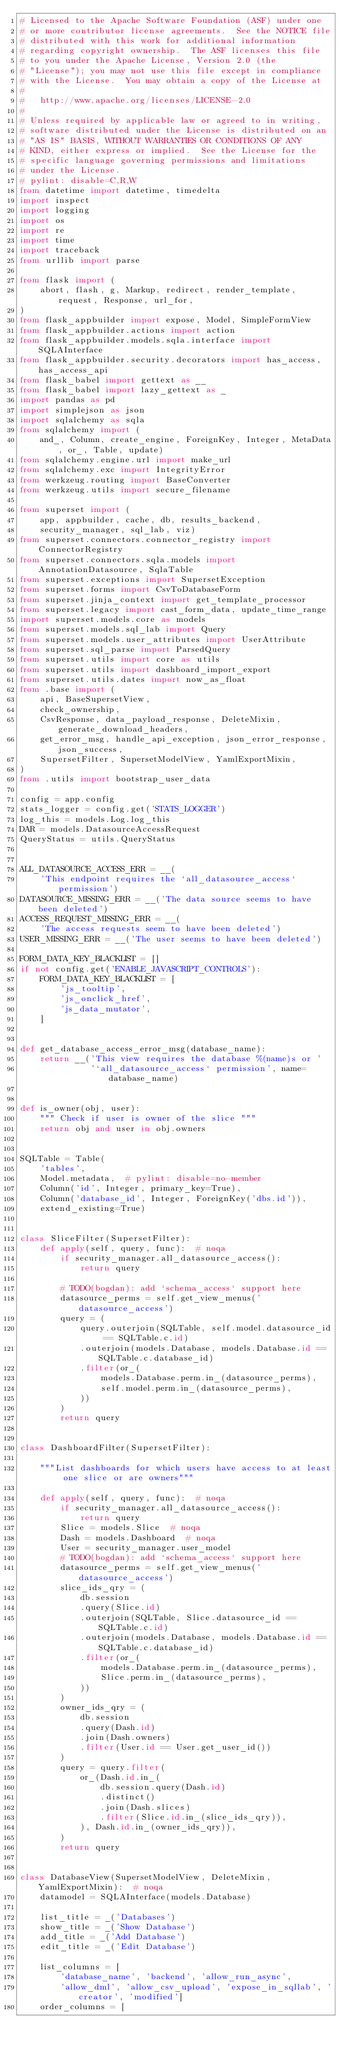Convert code to text. <code><loc_0><loc_0><loc_500><loc_500><_Python_># Licensed to the Apache Software Foundation (ASF) under one
# or more contributor license agreements.  See the NOTICE file
# distributed with this work for additional information
# regarding copyright ownership.  The ASF licenses this file
# to you under the Apache License, Version 2.0 (the
# "License"); you may not use this file except in compliance
# with the License.  You may obtain a copy of the License at
#
#   http://www.apache.org/licenses/LICENSE-2.0
#
# Unless required by applicable law or agreed to in writing,
# software distributed under the License is distributed on an
# "AS IS" BASIS, WITHOUT WARRANTIES OR CONDITIONS OF ANY
# KIND, either express or implied.  See the License for the
# specific language governing permissions and limitations
# under the License.
# pylint: disable=C,R,W
from datetime import datetime, timedelta
import inspect
import logging
import os
import re
import time
import traceback
from urllib import parse

from flask import (
    abort, flash, g, Markup, redirect, render_template, request, Response, url_for,
)
from flask_appbuilder import expose, Model, SimpleFormView
from flask_appbuilder.actions import action
from flask_appbuilder.models.sqla.interface import SQLAInterface
from flask_appbuilder.security.decorators import has_access, has_access_api
from flask_babel import gettext as __
from flask_babel import lazy_gettext as _
import pandas as pd
import simplejson as json
import sqlalchemy as sqla
from sqlalchemy import (
    and_, Column, create_engine, ForeignKey, Integer, MetaData, or_, Table, update)
from sqlalchemy.engine.url import make_url
from sqlalchemy.exc import IntegrityError
from werkzeug.routing import BaseConverter
from werkzeug.utils import secure_filename

from superset import (
    app, appbuilder, cache, db, results_backend,
    security_manager, sql_lab, viz)
from superset.connectors.connector_registry import ConnectorRegistry
from superset.connectors.sqla.models import AnnotationDatasource, SqlaTable
from superset.exceptions import SupersetException
from superset.forms import CsvToDatabaseForm
from superset.jinja_context import get_template_processor
from superset.legacy import cast_form_data, update_time_range
import superset.models.core as models
from superset.models.sql_lab import Query
from superset.models.user_attributes import UserAttribute
from superset.sql_parse import ParsedQuery
from superset.utils import core as utils
from superset.utils import dashboard_import_export
from superset.utils.dates import now_as_float
from .base import (
    api, BaseSupersetView,
    check_ownership,
    CsvResponse, data_payload_response, DeleteMixin, generate_download_headers,
    get_error_msg, handle_api_exception, json_error_response, json_success,
    SupersetFilter, SupersetModelView, YamlExportMixin,
)
from .utils import bootstrap_user_data

config = app.config
stats_logger = config.get('STATS_LOGGER')
log_this = models.Log.log_this
DAR = models.DatasourceAccessRequest
QueryStatus = utils.QueryStatus


ALL_DATASOURCE_ACCESS_ERR = __(
    'This endpoint requires the `all_datasource_access` permission')
DATASOURCE_MISSING_ERR = __('The data source seems to have been deleted')
ACCESS_REQUEST_MISSING_ERR = __(
    'The access requests seem to have been deleted')
USER_MISSING_ERR = __('The user seems to have been deleted')

FORM_DATA_KEY_BLACKLIST = []
if not config.get('ENABLE_JAVASCRIPT_CONTROLS'):
    FORM_DATA_KEY_BLACKLIST = [
        'js_tooltip',
        'js_onclick_href',
        'js_data_mutator',
    ]


def get_database_access_error_msg(database_name):
    return __('This view requires the database %(name)s or '
              '`all_datasource_access` permission', name=database_name)


def is_owner(obj, user):
    """ Check if user is owner of the slice """
    return obj and user in obj.owners


SQLTable = Table(
    'tables',
    Model.metadata,  # pylint: disable=no-member
    Column('id', Integer, primary_key=True),
    Column('database_id', Integer, ForeignKey('dbs.id')),
    extend_existing=True)


class SliceFilter(SupersetFilter):
    def apply(self, query, func):  # noqa
        if security_manager.all_datasource_access():
            return query

        # TODO(bogdan): add `schema_access` support here
        datasource_perms = self.get_view_menus('datasource_access')
        query = (
            query.outerjoin(SQLTable, self.model.datasource_id == SQLTable.c.id)
            .outerjoin(models.Database, models.Database.id == SQLTable.c.database_id)
            .filter(or_(
                models.Database.perm.in_(datasource_perms),
                self.model.perm.in_(datasource_perms),
            ))
        )
        return query


class DashboardFilter(SupersetFilter):

    """List dashboards for which users have access to at least one slice or are owners"""

    def apply(self, query, func):  # noqa
        if security_manager.all_datasource_access():
            return query
        Slice = models.Slice  # noqa
        Dash = models.Dashboard  # noqa
        User = security_manager.user_model
        # TODO(bogdan): add `schema_access` support here
        datasource_perms = self.get_view_menus('datasource_access')
        slice_ids_qry = (
            db.session
            .query(Slice.id)
            .outerjoin(SQLTable, Slice.datasource_id == SQLTable.c.id)
            .outerjoin(models.Database, models.Database.id == SQLTable.c.database_id)
            .filter(or_(
                models.Database.perm.in_(datasource_perms),
                Slice.perm.in_(datasource_perms),
            ))
        )
        owner_ids_qry = (
            db.session
            .query(Dash.id)
            .join(Dash.owners)
            .filter(User.id == User.get_user_id())
        )
        query = query.filter(
            or_(Dash.id.in_(
                db.session.query(Dash.id)
                .distinct()
                .join(Dash.slices)
                .filter(Slice.id.in_(slice_ids_qry)),
            ), Dash.id.in_(owner_ids_qry)),
        )
        return query


class DatabaseView(SupersetModelView, DeleteMixin, YamlExportMixin):  # noqa
    datamodel = SQLAInterface(models.Database)

    list_title = _('Databases')
    show_title = _('Show Database')
    add_title = _('Add Database')
    edit_title = _('Edit Database')

    list_columns = [
        'database_name', 'backend', 'allow_run_async',
        'allow_dml', 'allow_csv_upload', 'expose_in_sqllab', 'creator', 'modified']
    order_columns = [</code> 